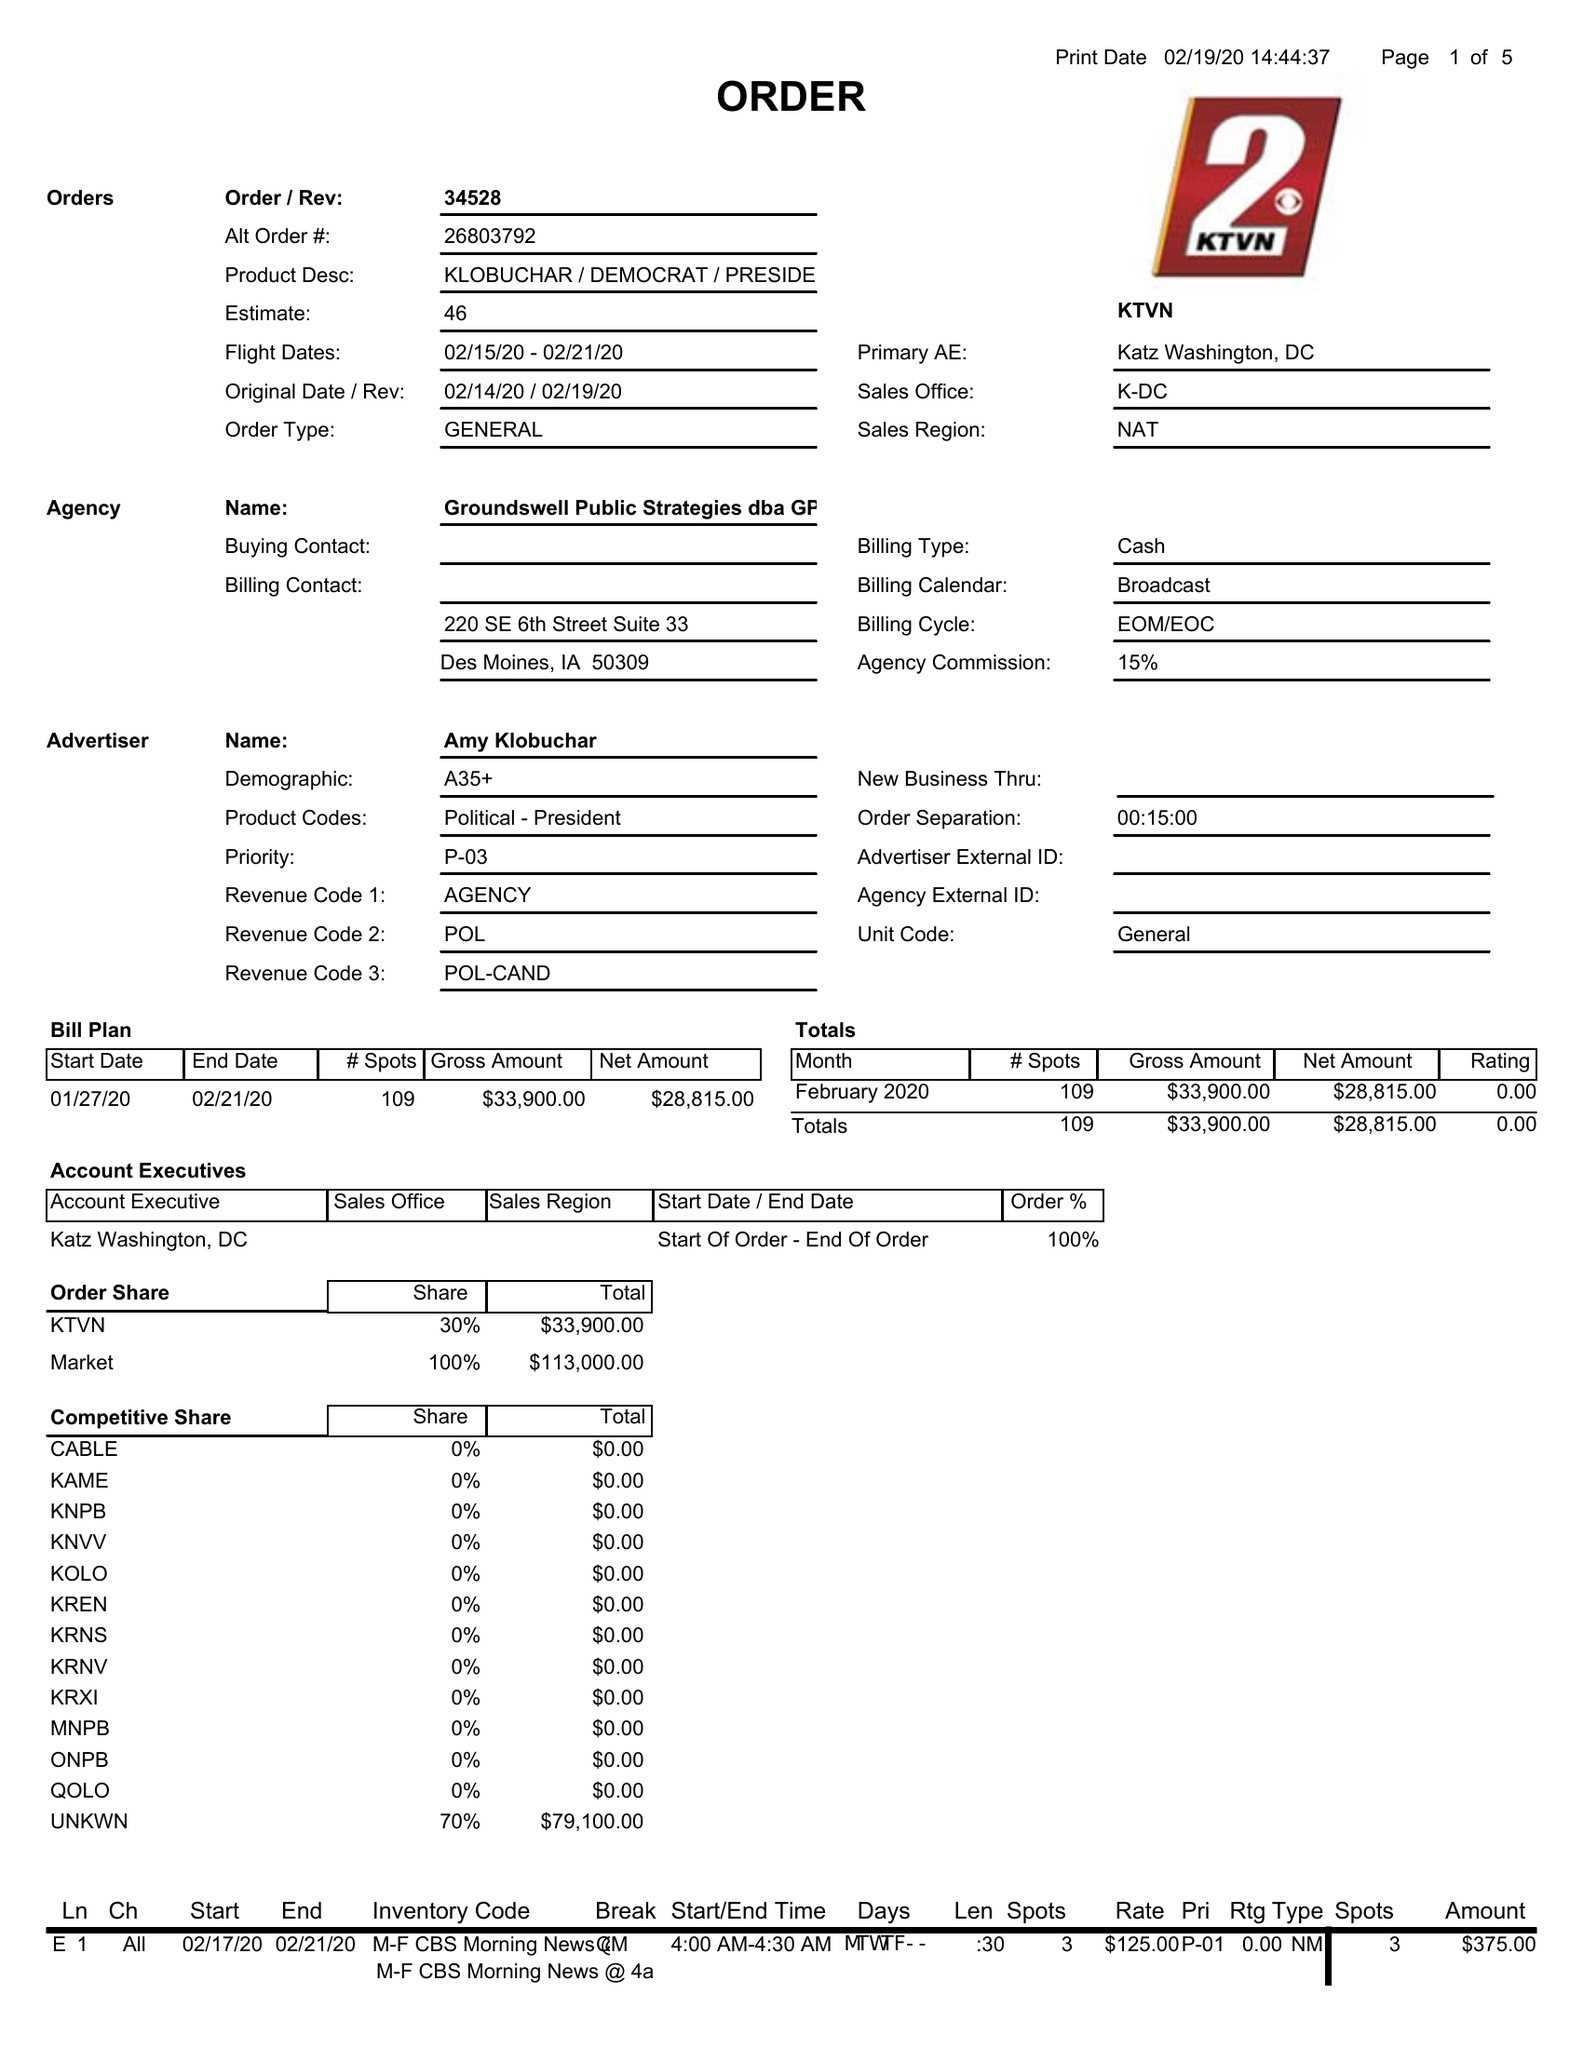What is the value for the flight_to?
Answer the question using a single word or phrase. 02/21/20 